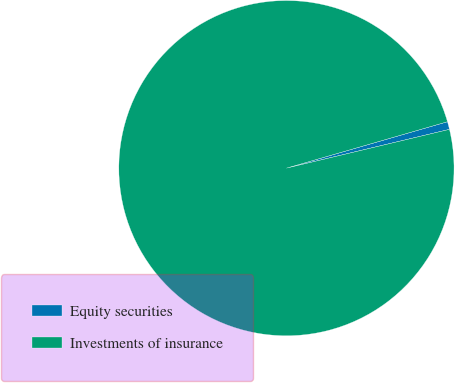Convert chart to OTSL. <chart><loc_0><loc_0><loc_500><loc_500><pie_chart><fcel>Equity securities<fcel>Investments of insurance<nl><fcel>0.75%<fcel>99.25%<nl></chart> 